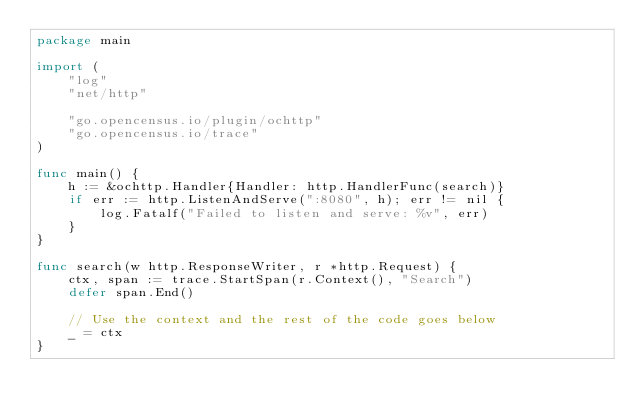<code> <loc_0><loc_0><loc_500><loc_500><_Go_>package main

import (
	"log"
	"net/http"

	"go.opencensus.io/plugin/ochttp"
	"go.opencensus.io/trace"
)

func main() {
	h := &ochttp.Handler{Handler: http.HandlerFunc(search)}
	if err := http.ListenAndServe(":8080", h); err != nil {
		log.Fatalf("Failed to listen and serve: %v", err)
	}
}

func search(w http.ResponseWriter, r *http.Request) {
	ctx, span := trace.StartSpan(r.Context(), "Search")
	defer span.End()

	// Use the context and the rest of the code goes below
	_ = ctx
}
</code> 